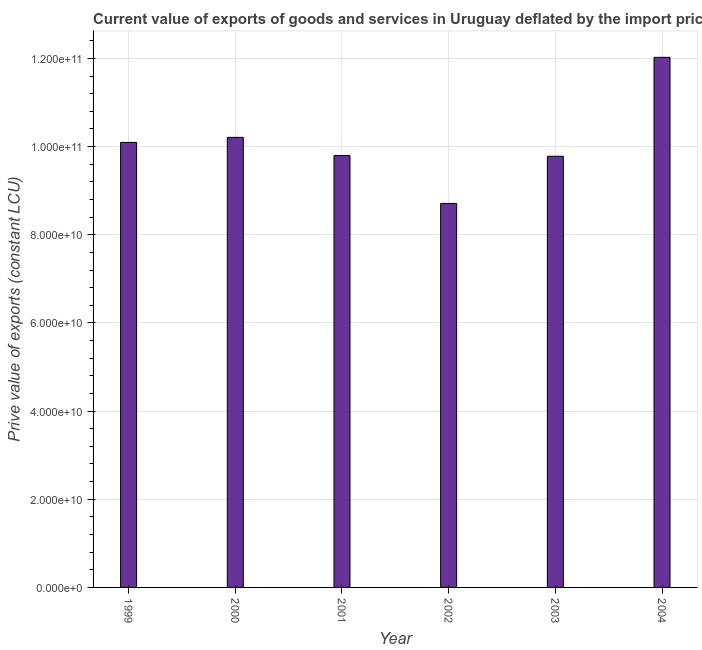What is the title of the graph?
Provide a succinct answer. Current value of exports of goods and services in Uruguay deflated by the import price index. What is the label or title of the X-axis?
Your response must be concise. Year. What is the label or title of the Y-axis?
Provide a short and direct response. Prive value of exports (constant LCU). What is the price value of exports in 2003?
Ensure brevity in your answer.  9.78e+1. Across all years, what is the maximum price value of exports?
Give a very brief answer. 1.20e+11. Across all years, what is the minimum price value of exports?
Offer a very short reply. 8.71e+1. In which year was the price value of exports minimum?
Provide a succinct answer. 2002. What is the sum of the price value of exports?
Provide a short and direct response. 6.06e+11. What is the difference between the price value of exports in 1999 and 2002?
Your answer should be very brief. 1.38e+1. What is the average price value of exports per year?
Keep it short and to the point. 1.01e+11. What is the median price value of exports?
Offer a very short reply. 9.95e+1. In how many years, is the price value of exports greater than 8000000000 LCU?
Provide a succinct answer. 6. Do a majority of the years between 2003 and 2000 (inclusive) have price value of exports greater than 80000000000 LCU?
Offer a very short reply. Yes. What is the ratio of the price value of exports in 2002 to that in 2003?
Ensure brevity in your answer.  0.89. Is the price value of exports in 2001 less than that in 2002?
Your answer should be very brief. No. What is the difference between the highest and the second highest price value of exports?
Ensure brevity in your answer.  1.82e+1. What is the difference between the highest and the lowest price value of exports?
Your answer should be compact. 3.31e+1. In how many years, is the price value of exports greater than the average price value of exports taken over all years?
Offer a terse response. 2. Are all the bars in the graph horizontal?
Offer a terse response. No. How many years are there in the graph?
Offer a terse response. 6. Are the values on the major ticks of Y-axis written in scientific E-notation?
Offer a terse response. Yes. What is the Prive value of exports (constant LCU) of 1999?
Make the answer very short. 1.01e+11. What is the Prive value of exports (constant LCU) in 2000?
Provide a succinct answer. 1.02e+11. What is the Prive value of exports (constant LCU) of 2001?
Offer a terse response. 9.80e+1. What is the Prive value of exports (constant LCU) of 2002?
Offer a terse response. 8.71e+1. What is the Prive value of exports (constant LCU) in 2003?
Ensure brevity in your answer.  9.78e+1. What is the Prive value of exports (constant LCU) in 2004?
Your response must be concise. 1.20e+11. What is the difference between the Prive value of exports (constant LCU) in 1999 and 2000?
Offer a very short reply. -1.14e+09. What is the difference between the Prive value of exports (constant LCU) in 1999 and 2001?
Ensure brevity in your answer.  2.98e+09. What is the difference between the Prive value of exports (constant LCU) in 1999 and 2002?
Your answer should be very brief. 1.38e+1. What is the difference between the Prive value of exports (constant LCU) in 1999 and 2003?
Your answer should be very brief. 3.14e+09. What is the difference between the Prive value of exports (constant LCU) in 1999 and 2004?
Keep it short and to the point. -1.93e+1. What is the difference between the Prive value of exports (constant LCU) in 2000 and 2001?
Your response must be concise. 4.12e+09. What is the difference between the Prive value of exports (constant LCU) in 2000 and 2002?
Your response must be concise. 1.50e+1. What is the difference between the Prive value of exports (constant LCU) in 2000 and 2003?
Your answer should be compact. 4.28e+09. What is the difference between the Prive value of exports (constant LCU) in 2000 and 2004?
Your answer should be very brief. -1.82e+1. What is the difference between the Prive value of exports (constant LCU) in 2001 and 2002?
Your answer should be compact. 1.09e+1. What is the difference between the Prive value of exports (constant LCU) in 2001 and 2003?
Make the answer very short. 1.57e+08. What is the difference between the Prive value of exports (constant LCU) in 2001 and 2004?
Your answer should be compact. -2.23e+1. What is the difference between the Prive value of exports (constant LCU) in 2002 and 2003?
Give a very brief answer. -1.07e+1. What is the difference between the Prive value of exports (constant LCU) in 2002 and 2004?
Ensure brevity in your answer.  -3.31e+1. What is the difference between the Prive value of exports (constant LCU) in 2003 and 2004?
Your answer should be very brief. -2.24e+1. What is the ratio of the Prive value of exports (constant LCU) in 1999 to that in 2000?
Offer a very short reply. 0.99. What is the ratio of the Prive value of exports (constant LCU) in 1999 to that in 2002?
Keep it short and to the point. 1.16. What is the ratio of the Prive value of exports (constant LCU) in 1999 to that in 2003?
Provide a short and direct response. 1.03. What is the ratio of the Prive value of exports (constant LCU) in 1999 to that in 2004?
Provide a short and direct response. 0.84. What is the ratio of the Prive value of exports (constant LCU) in 2000 to that in 2001?
Keep it short and to the point. 1.04. What is the ratio of the Prive value of exports (constant LCU) in 2000 to that in 2002?
Keep it short and to the point. 1.17. What is the ratio of the Prive value of exports (constant LCU) in 2000 to that in 2003?
Offer a very short reply. 1.04. What is the ratio of the Prive value of exports (constant LCU) in 2000 to that in 2004?
Give a very brief answer. 0.85. What is the ratio of the Prive value of exports (constant LCU) in 2001 to that in 2002?
Your response must be concise. 1.12. What is the ratio of the Prive value of exports (constant LCU) in 2001 to that in 2003?
Provide a succinct answer. 1. What is the ratio of the Prive value of exports (constant LCU) in 2001 to that in 2004?
Your answer should be compact. 0.81. What is the ratio of the Prive value of exports (constant LCU) in 2002 to that in 2003?
Offer a very short reply. 0.89. What is the ratio of the Prive value of exports (constant LCU) in 2002 to that in 2004?
Give a very brief answer. 0.72. What is the ratio of the Prive value of exports (constant LCU) in 2003 to that in 2004?
Give a very brief answer. 0.81. 